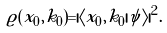<formula> <loc_0><loc_0><loc_500><loc_500>\varrho ( x _ { 0 } , k _ { 0 } ) = | \langle x _ { 0 } , k _ { 0 } | \psi \rangle | ^ { 2 } .</formula> 